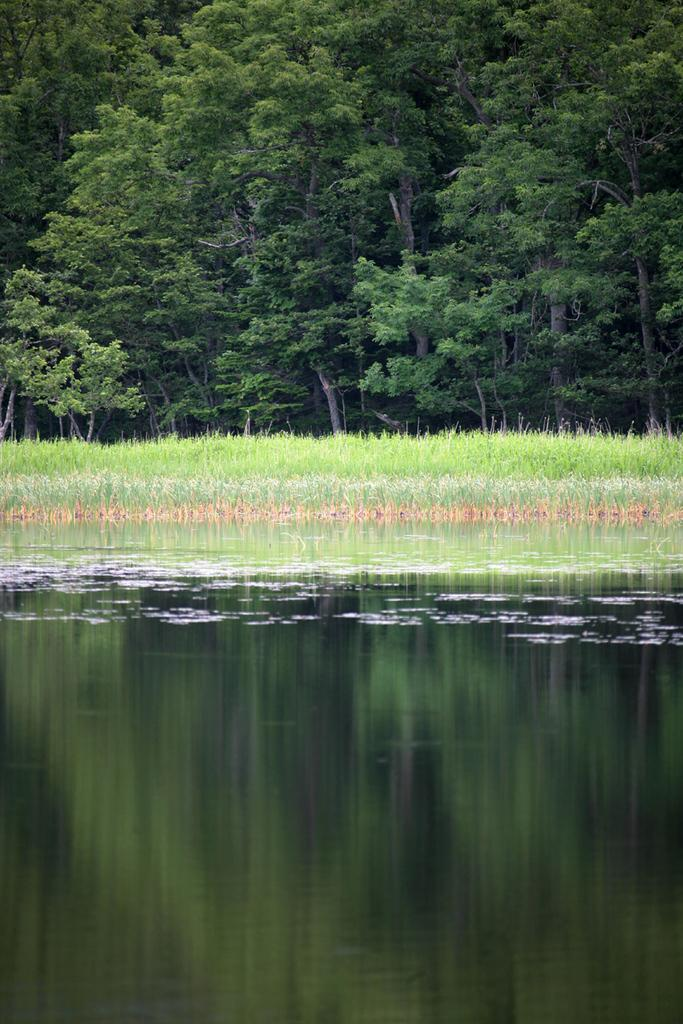What is the main subject in the center of the image? There is water in the center of the image. What type of vegetation can be seen in the background of the image? There is grass and trees in the background of the image. What type of cabbage is being waved good-bye in the image? There is no cabbage or good-bye gesture present in the image. 